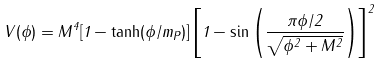<formula> <loc_0><loc_0><loc_500><loc_500>V ( \phi ) = M ^ { 4 } [ 1 - \tanh ( \phi / m _ { P } ) ] \left [ 1 - \sin \left ( \frac { \pi \phi / 2 } { \sqrt { \phi ^ { 2 } + M ^ { 2 } } } \right ) \right ] ^ { 2 }</formula> 